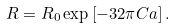<formula> <loc_0><loc_0><loc_500><loc_500>R = R _ { 0 } \exp \left [ - 3 2 \pi C a \right ] .</formula> 